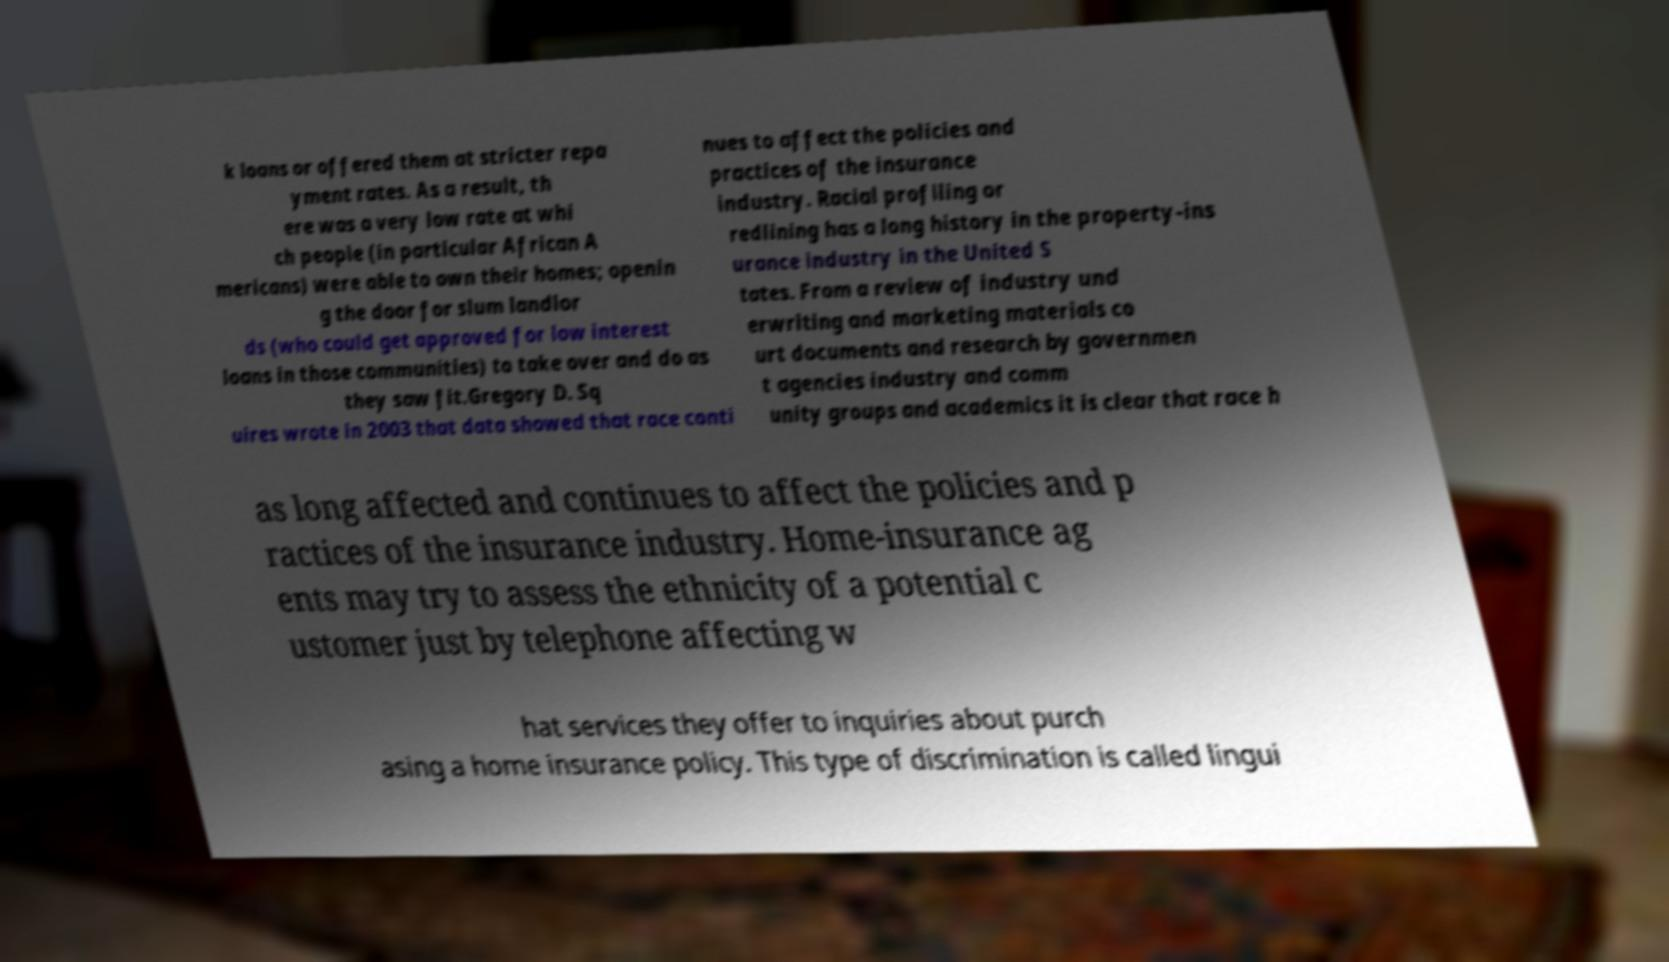Could you extract and type out the text from this image? k loans or offered them at stricter repa yment rates. As a result, th ere was a very low rate at whi ch people (in particular African A mericans) were able to own their homes; openin g the door for slum landlor ds (who could get approved for low interest loans in those communities) to take over and do as they saw fit.Gregory D. Sq uires wrote in 2003 that data showed that race conti nues to affect the policies and practices of the insurance industry. Racial profiling or redlining has a long history in the property-ins urance industry in the United S tates. From a review of industry und erwriting and marketing materials co urt documents and research by governmen t agencies industry and comm unity groups and academics it is clear that race h as long affected and continues to affect the policies and p ractices of the insurance industry. Home-insurance ag ents may try to assess the ethnicity of a potential c ustomer just by telephone affecting w hat services they offer to inquiries about purch asing a home insurance policy. This type of discrimination is called lingui 